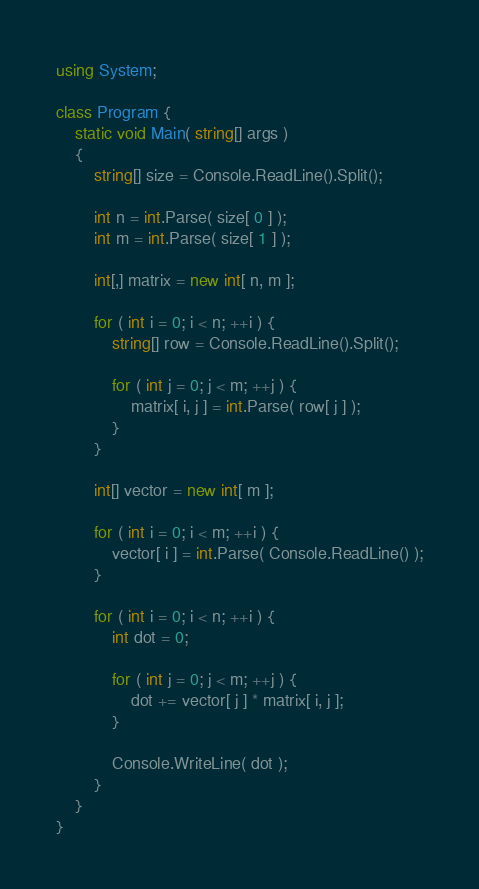Convert code to text. <code><loc_0><loc_0><loc_500><loc_500><_C#_>using System;

class Program {
    static void Main( string[] args )
    {
        string[] size = Console.ReadLine().Split();

        int n = int.Parse( size[ 0 ] );
        int m = int.Parse( size[ 1 ] );

        int[,] matrix = new int[ n, m ];

        for ( int i = 0; i < n; ++i ) {
            string[] row = Console.ReadLine().Split();

            for ( int j = 0; j < m; ++j ) {
                matrix[ i, j ] = int.Parse( row[ j ] );
            }
        }

        int[] vector = new int[ m ];

        for ( int i = 0; i < m; ++i ) {
            vector[ i ] = int.Parse( Console.ReadLine() );
        }

        for ( int i = 0; i < n; ++i ) {
            int dot = 0;

            for ( int j = 0; j < m; ++j ) {
                dot += vector[ j ] * matrix[ i, j ];
            }

            Console.WriteLine( dot );
        }
    }
}</code> 